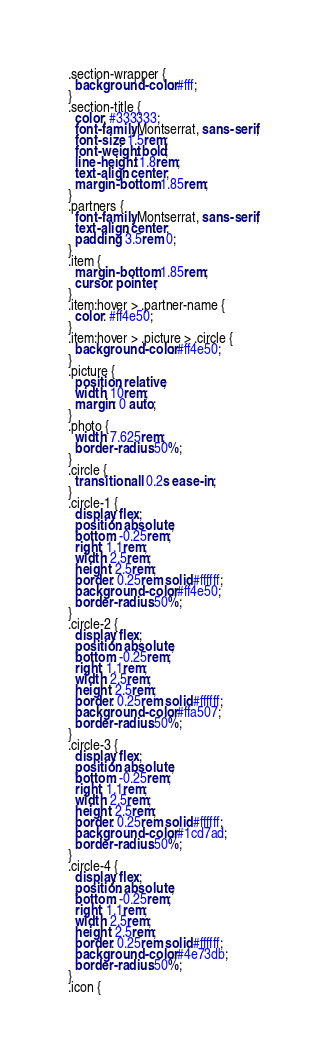Convert code to text. <code><loc_0><loc_0><loc_500><loc_500><_CSS_>.section-wrapper {
  background-color: #fff;
}
.section-title {
  color: #333333;
  font-family: Montserrat, sans-serif;
  font-size: 1.5rem;
  font-weight: bold;
  line-height: 1.8rem;
  text-align: center;
  margin-bottom: 1.85rem;
}
.partners {
  font-family: Montserrat, sans-serif;
  text-align: center;
  padding: 3.5rem 0;
}
.item {
  margin-bottom: 1.85rem;
  cursor: pointer;
}
.item:hover > .partner-name {
  color: #ff4e50;
}
.item:hover > .picture > .circle {
  background-color: #ff4e50;
}
.picture {
  position: relative;
  width: 10rem;
  margin: 0 auto;
}
.photo {
  width: 7.625rem;
  border-radius: 50%;
}
.circle {
  transition: all 0.2s ease-in;
}
.circle-1 {
  display: flex;
  position: absolute;
  bottom: -0.25rem;
  right: 1.1rem;
  width: 2.5rem;
  height: 2.5rem;
  border: 0.25rem solid #ffffff;
  background-color: #ff4e50;
  border-radius: 50%;
}
.circle-2 {
  display: flex;
  position: absolute;
  bottom: -0.25rem;
  right: 1.1rem;
  width: 2.5rem;
  height: 2.5rem;
  border: 0.25rem solid #ffffff;
  background-color: #ffa507;
  border-radius: 50%;
}
.circle-3 {
  display: flex;
  position: absolute;
  bottom: -0.25rem;
  right: 1.1rem;
  width: 2.5rem;
  height: 2.5rem;
  border: 0.25rem solid #ffffff;
  background-color: #1cd7ad;
  border-radius: 50%;
}
.circle-4 {
  display: flex;
  position: absolute;
  bottom: -0.25rem;
  right: 1.1rem;
  width: 2.5rem;
  height: 2.5rem;
  border: 0.25rem solid #ffffff;
  background-color: #4e73db;
  border-radius: 50%;
}
.icon {</code> 